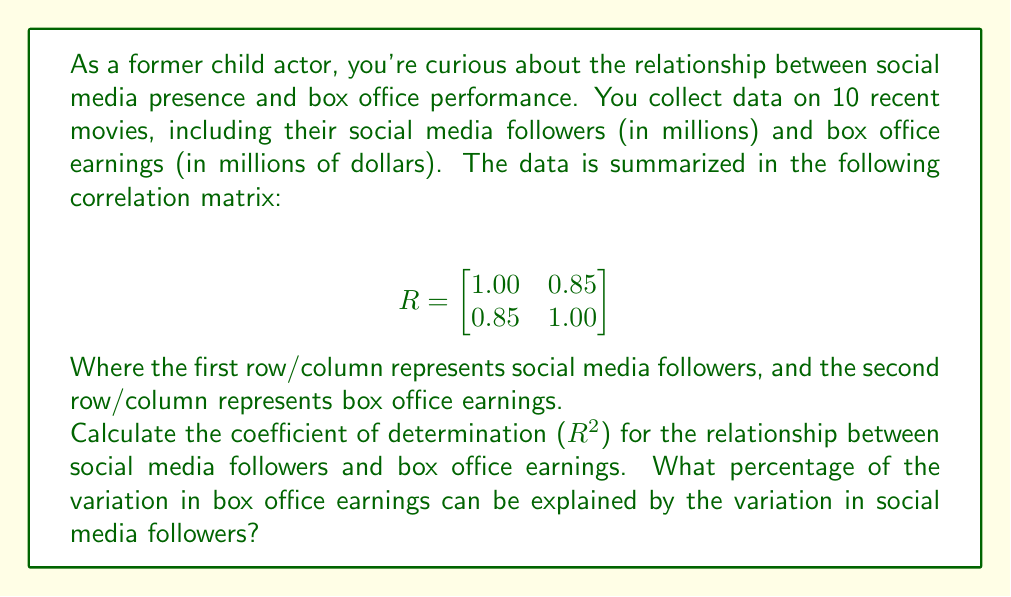Teach me how to tackle this problem. To solve this problem, we'll follow these steps:

1. Identify the correlation coefficient:
   The correlation coefficient (r) between social media followers and box office earnings is given in the off-diagonal elements of the correlation matrix. In this case, $r = 0.85$.

2. Calculate the coefficient of determination ($R^2$):
   The coefficient of determination is the square of the correlation coefficient.
   
   $R^2 = r^2 = (0.85)^2 = 0.7225$

3. Convert to percentage:
   To express this as a percentage, we multiply by 100.
   
   $0.7225 \times 100 = 72.25\%$

The coefficient of determination ($R^2$) tells us the proportion of variance in the dependent variable (box office earnings) that can be predicted from the independent variable (social media followers).

Therefore, 72.25% of the variation in box office earnings can be explained by the variation in social media followers.
Answer: 72.25% 